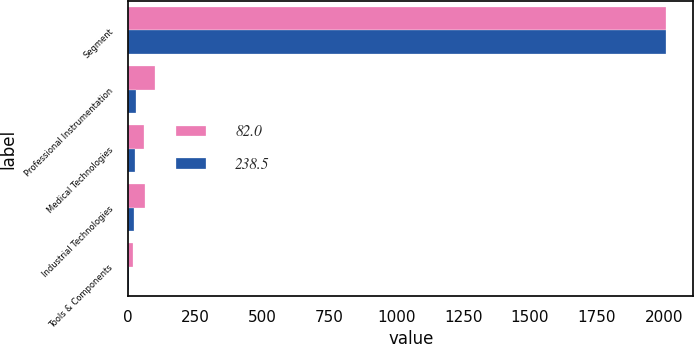<chart> <loc_0><loc_0><loc_500><loc_500><stacked_bar_chart><ecel><fcel>Segment<fcel>Professional Instrumentation<fcel>Medical Technologies<fcel>Industrial Technologies<fcel>Tools & Components<nl><fcel>82<fcel>2009<fcel>99<fcel>60.5<fcel>60.7<fcel>18.3<nl><fcel>238.5<fcel>2008<fcel>28.8<fcel>26.1<fcel>23.1<fcel>4<nl></chart> 